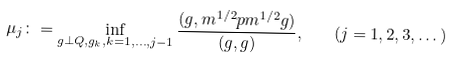<formula> <loc_0><loc_0><loc_500><loc_500>\mu _ { j } \colon = \inf _ { g \perp Q , g _ { k } , k = 1 , \dots , j - 1 } \frac { ( g , \L m ^ { 1 / 2 } \L p \L m ^ { 1 / 2 } g ) } { ( g , g ) } , \quad ( j = 1 , 2 , 3 , \dots )</formula> 